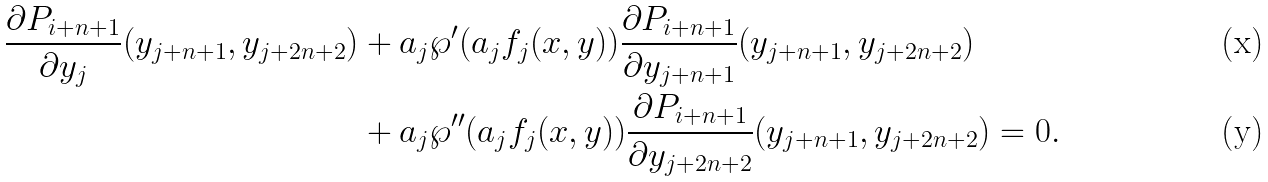Convert formula to latex. <formula><loc_0><loc_0><loc_500><loc_500>\frac { \partial P _ { i + n + 1 } } { \partial y _ { j } } ( y _ { j + n + 1 } , y _ { j + 2 n + 2 } ) & + a _ { j } \wp ^ { \prime } ( a _ { j } f _ { j } ( x , y ) ) \frac { \partial P _ { i + n + 1 } } { \partial y _ { j + n + 1 } } ( y _ { j + n + 1 } , y _ { j + 2 n + 2 } ) \\ & + a _ { j } \wp ^ { \prime \prime } ( a _ { j } f _ { j } ( x , y ) ) \frac { \partial P _ { i + n + 1 } } { \partial y _ { j + 2 n + 2 } } ( y _ { j + n + 1 } , y _ { j + 2 n + 2 } ) = 0 .</formula> 